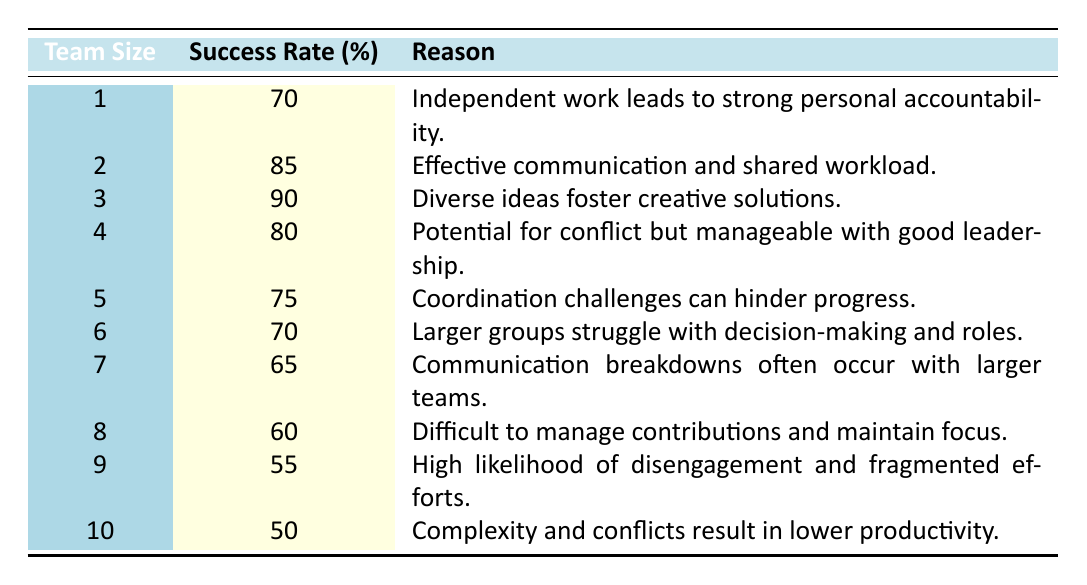What is the success rate for a team size of 3? The table directly shows that the success rate for a team size of 3 is listed in the corresponding row.
Answer: 90 Which team size has the highest success rate? Looking through the success rates provided in the table, team size 3 has the highest success rate of 90 percent.
Answer: 3 What is the success rate difference between team sizes 4 and 5? The success rate for team size 4 is 80 percent, and for team size 5, it is 75 percent. The difference is 80 - 75 = 5 percent.
Answer: 5 Is the statement "A team of 6 is more successful than a team of 5" true? Referring to the table, the success rate for a team size of 6 is 70 percent, and for team size 5, it is 75 percent. Since 70 is less than 75, the statement is false.
Answer: No What is the average success rate for team sizes 1 through 4? The success rates for team sizes 1 to 4 are 70, 85, 90, and 80 respectively. To find the average, sum them: 70 + 85 + 90 + 80 = 325. Then, divide the sum by the number of teams: 325 / 4 = 81.25.
Answer: 81.25 Which team size experiences potential communication breakdowns according to the data? The table indicates that team size 7 has communication breakdowns often occur, as stated in the reason for that team size.
Answer: 7 How many team sizes have a success rate above 70 percent? Referring to the table, we see that team sizes 1 (70), 2 (85), 3 (90), and 4 (80) have success rates above 70 percent. Thus, there are 4 team sizes with rates above 70.
Answer: 4 What reason is given for the low success rate of teams of size 10? According to the table, teams of size 10 have a success rate of 50 percent, attributed to complexity and conflicts resulting in lower productivity.
Answer: Complexity and conflicts How many team sizes have success rates below 65 percent? The success rates below 65 percent are for team sizes 8 (60), 9 (55), and 10 (50) according to the table. Thus, there are 3 team sizes below this threshold.
Answer: 3 What is the trend in success rates as team sizes increase from 1 to 10? Observing the success rates from team sizes 1 to 10, we can infer that the success rates initially rise from team size 1 to 3, peak at 90 for size 3, and then gradually decline as team size increases to 10.
Answer: U-shaped trend 